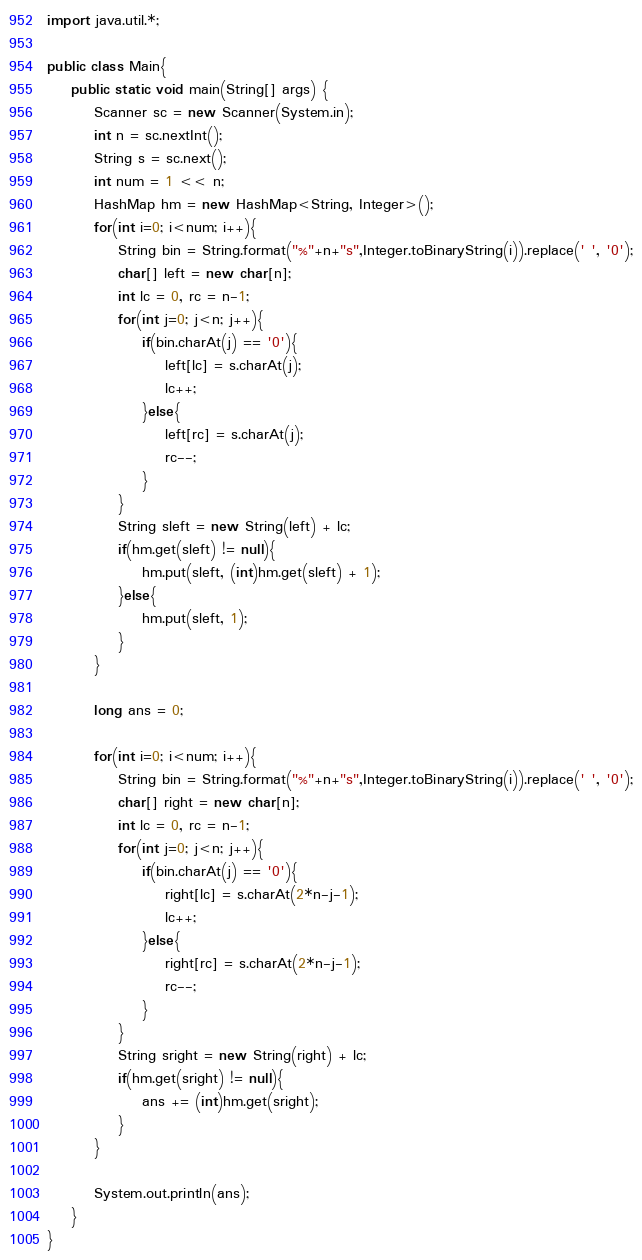Convert code to text. <code><loc_0><loc_0><loc_500><loc_500><_Java_>import java.util.*;

public class Main{
    public static void main(String[] args) {
        Scanner sc = new Scanner(System.in);
        int n = sc.nextInt();
        String s = sc.next();
        int num = 1 << n;
        HashMap hm = new HashMap<String, Integer>();
        for(int i=0; i<num; i++){
            String bin = String.format("%"+n+"s",Integer.toBinaryString(i)).replace(' ', '0');
            char[] left = new char[n];
            int lc = 0, rc = n-1;
            for(int j=0; j<n; j++){
                if(bin.charAt(j) == '0'){
                    left[lc] = s.charAt(j);
                    lc++;
                }else{
                    left[rc] = s.charAt(j);
                    rc--;
                }
            }
            String sleft = new String(left) + lc;
            if(hm.get(sleft) != null){
                hm.put(sleft, (int)hm.get(sleft) + 1);
            }else{
                hm.put(sleft, 1);
            }
        }

        long ans = 0;

        for(int i=0; i<num; i++){
            String bin = String.format("%"+n+"s",Integer.toBinaryString(i)).replace(' ', '0');
            char[] right = new char[n];
            int lc = 0, rc = n-1;
            for(int j=0; j<n; j++){
                if(bin.charAt(j) == '0'){
                    right[lc] = s.charAt(2*n-j-1);
                    lc++;
                }else{
                    right[rc] = s.charAt(2*n-j-1);
                    rc--;
                }
            }
            String sright = new String(right) + lc;
            if(hm.get(sright) != null){
                ans += (int)hm.get(sright);
            }
        }

        System.out.println(ans);
    }
}</code> 